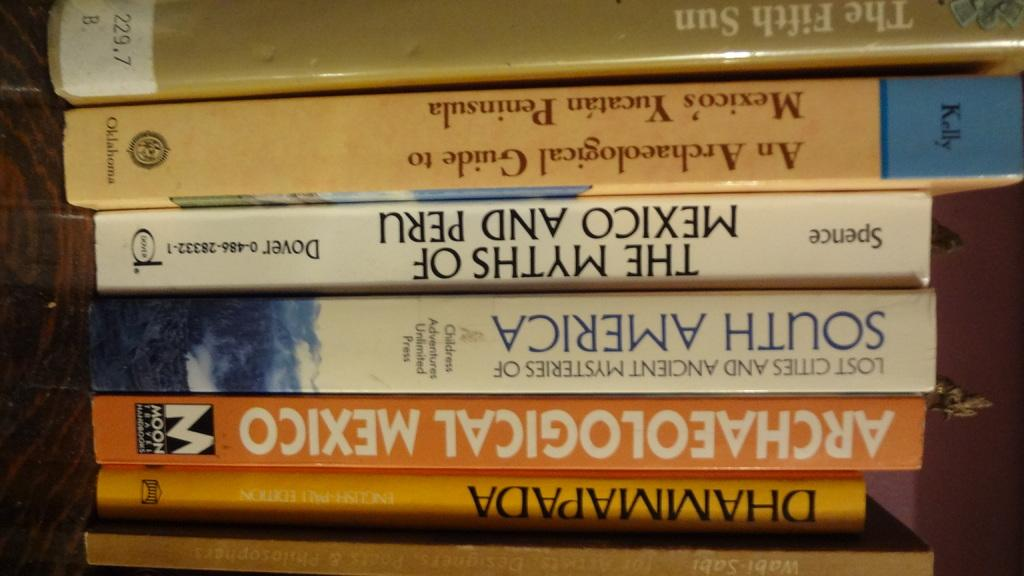<image>
Write a terse but informative summary of the picture. A group of books stacked upside down, with at least one about archaeology. 